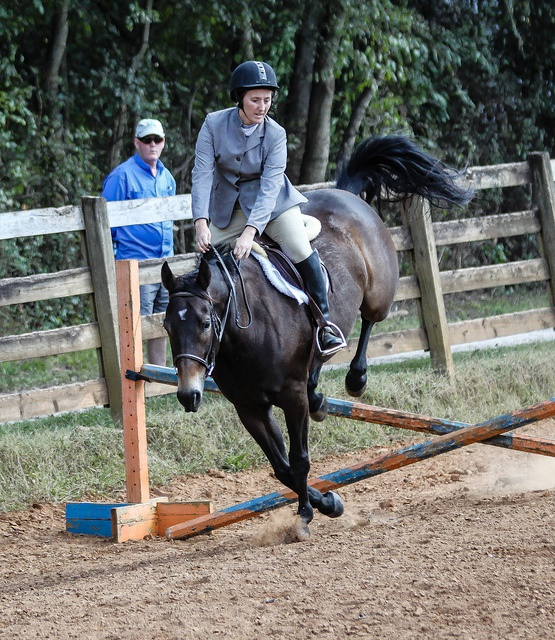Describe the objects in this image and their specific colors. I can see horse in black, gray, and darkgray tones, people in black, gray, and lightgray tones, and people in black, blue, lightblue, and lightgray tones in this image. 